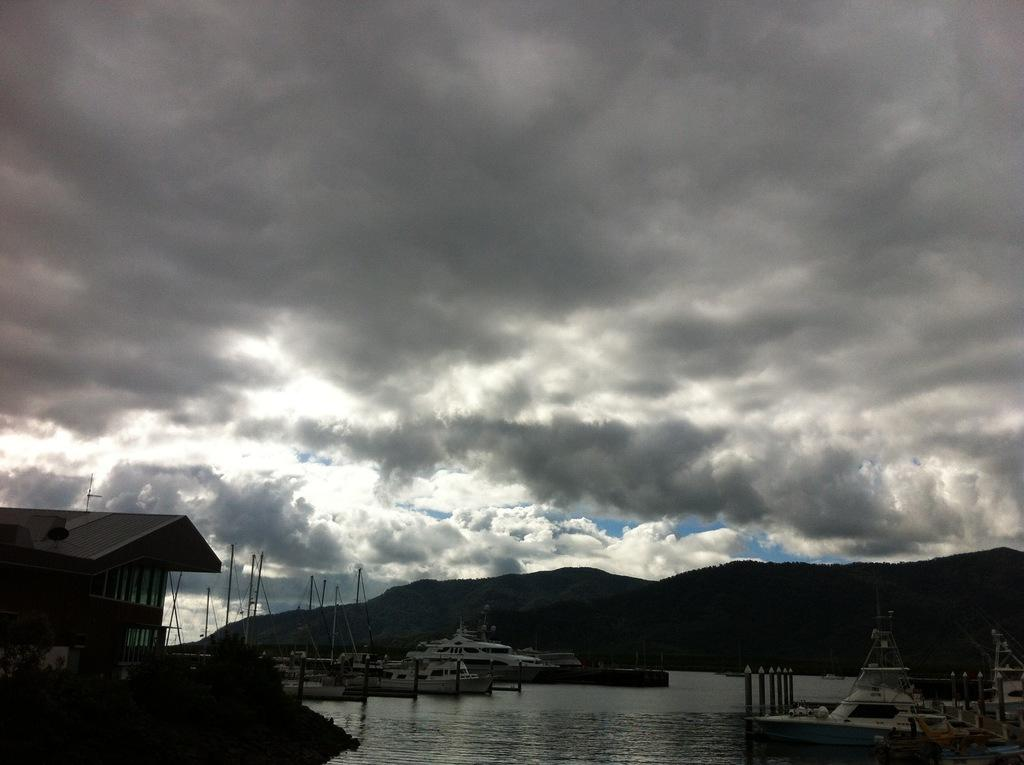What is the primary element in the image? There is water in the image. What else can be seen in the water? There are boats in the image. What structure is located on the left side of the image? There is a building on the left side of the image. What type of natural feature is visible in the background of the image? There are hills visible in the background of the image. What is visible at the top of the image? The sky is visible in the image, and clouds are present in the sky. How many chairs are placed around the match in the image? There is no match or chairs present in the image. 